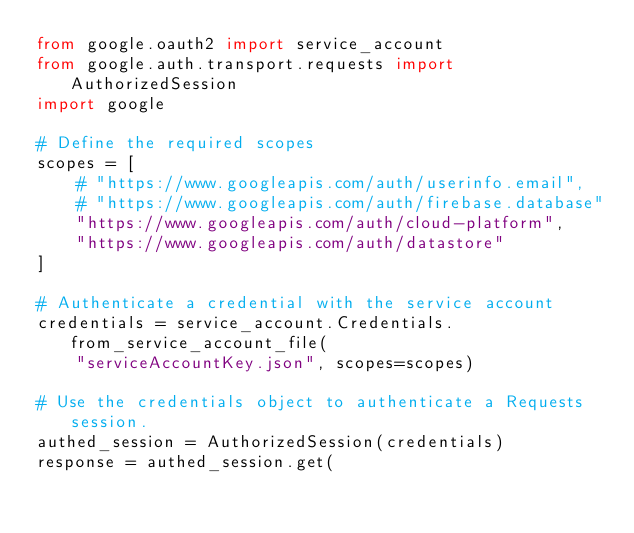<code> <loc_0><loc_0><loc_500><loc_500><_Python_>from google.oauth2 import service_account
from google.auth.transport.requests import AuthorizedSession
import google

# Define the required scopes
scopes = [
    # "https://www.googleapis.com/auth/userinfo.email",
    # "https://www.googleapis.com/auth/firebase.database"
    "https://www.googleapis.com/auth/cloud-platform",
    "https://www.googleapis.com/auth/datastore"
]

# Authenticate a credential with the service account
credentials = service_account.Credentials.from_service_account_file(
    "serviceAccountKey.json", scopes=scopes)

# Use the credentials object to authenticate a Requests session.
authed_session = AuthorizedSession(credentials)
response = authed_session.get(</code> 